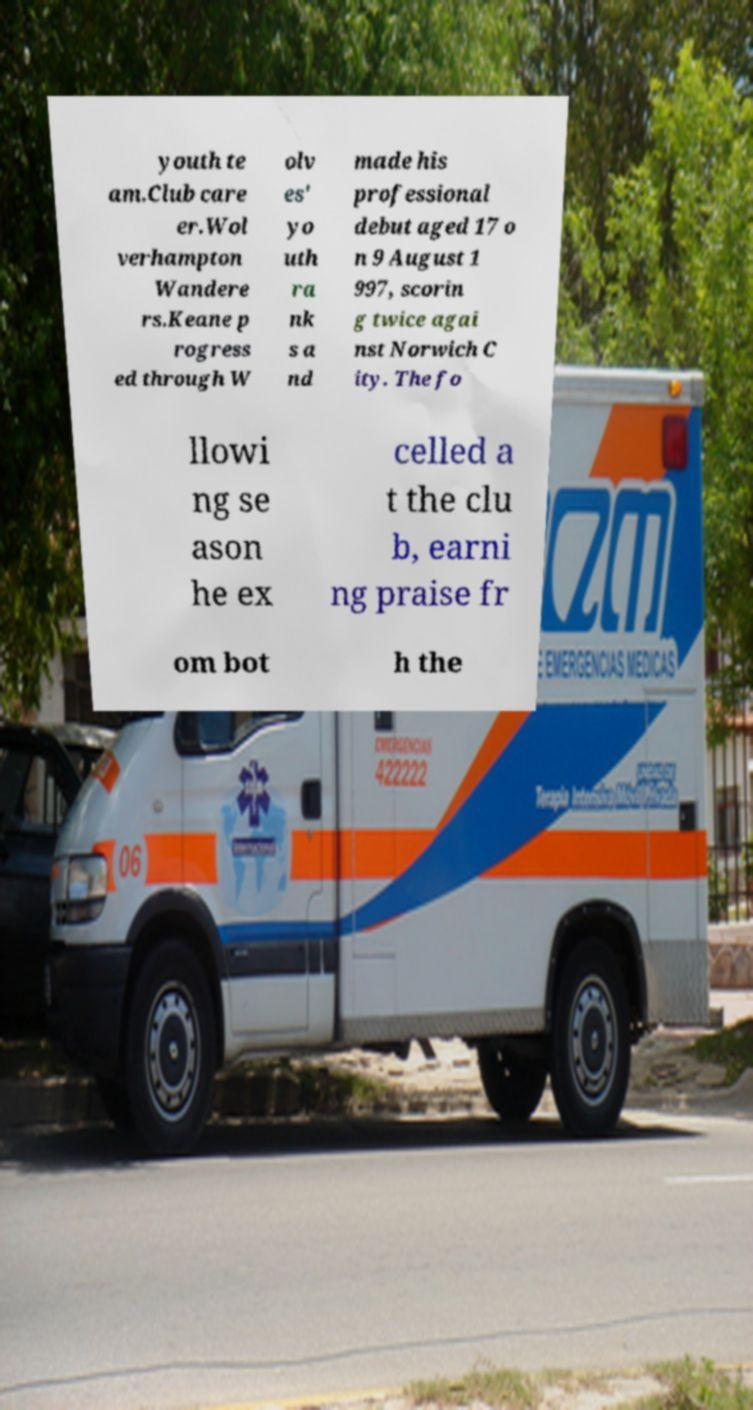What messages or text are displayed in this image? I need them in a readable, typed format. youth te am.Club care er.Wol verhampton Wandere rs.Keane p rogress ed through W olv es' yo uth ra nk s a nd made his professional debut aged 17 o n 9 August 1 997, scorin g twice agai nst Norwich C ity. The fo llowi ng se ason he ex celled a t the clu b, earni ng praise fr om bot h the 